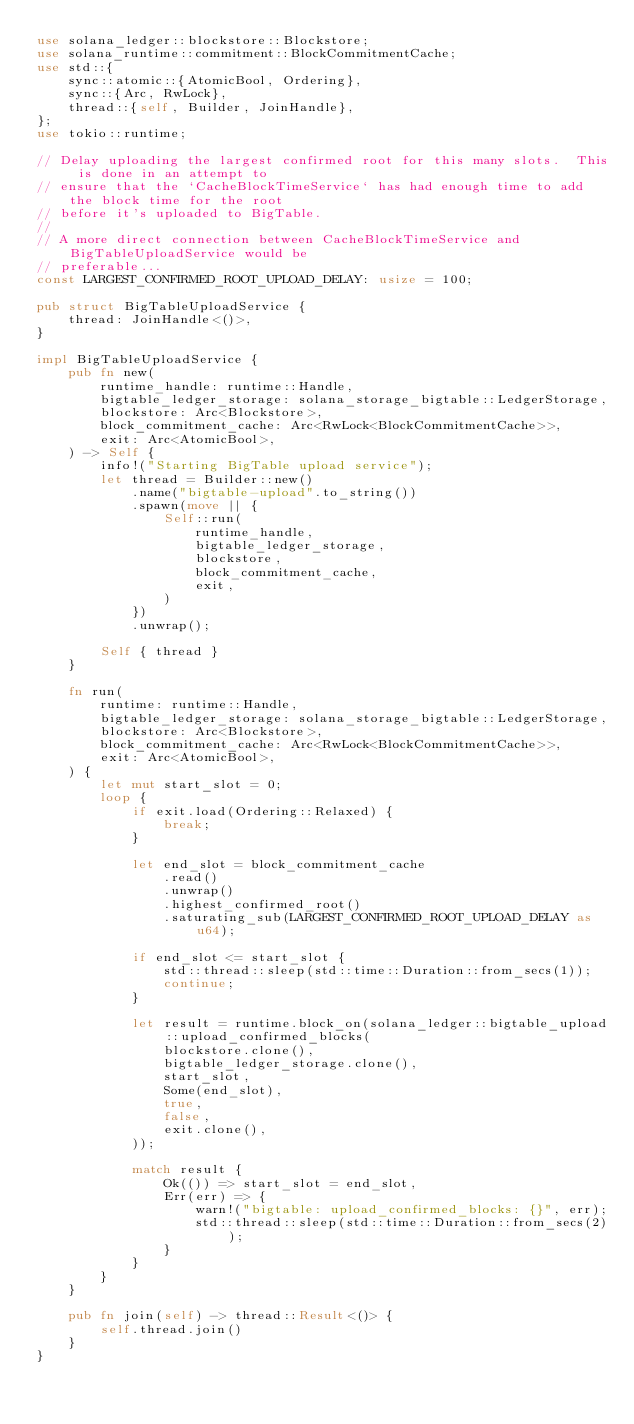Convert code to text. <code><loc_0><loc_0><loc_500><loc_500><_Rust_>use solana_ledger::blockstore::Blockstore;
use solana_runtime::commitment::BlockCommitmentCache;
use std::{
    sync::atomic::{AtomicBool, Ordering},
    sync::{Arc, RwLock},
    thread::{self, Builder, JoinHandle},
};
use tokio::runtime;

// Delay uploading the largest confirmed root for this many slots.  This is done in an attempt to
// ensure that the `CacheBlockTimeService` has had enough time to add the block time for the root
// before it's uploaded to BigTable.
//
// A more direct connection between CacheBlockTimeService and BigTableUploadService would be
// preferable...
const LARGEST_CONFIRMED_ROOT_UPLOAD_DELAY: usize = 100;

pub struct BigTableUploadService {
    thread: JoinHandle<()>,
}

impl BigTableUploadService {
    pub fn new(
        runtime_handle: runtime::Handle,
        bigtable_ledger_storage: solana_storage_bigtable::LedgerStorage,
        blockstore: Arc<Blockstore>,
        block_commitment_cache: Arc<RwLock<BlockCommitmentCache>>,
        exit: Arc<AtomicBool>,
    ) -> Self {
        info!("Starting BigTable upload service");
        let thread = Builder::new()
            .name("bigtable-upload".to_string())
            .spawn(move || {
                Self::run(
                    runtime_handle,
                    bigtable_ledger_storage,
                    blockstore,
                    block_commitment_cache,
                    exit,
                )
            })
            .unwrap();

        Self { thread }
    }

    fn run(
        runtime: runtime::Handle,
        bigtable_ledger_storage: solana_storage_bigtable::LedgerStorage,
        blockstore: Arc<Blockstore>,
        block_commitment_cache: Arc<RwLock<BlockCommitmentCache>>,
        exit: Arc<AtomicBool>,
    ) {
        let mut start_slot = 0;
        loop {
            if exit.load(Ordering::Relaxed) {
                break;
            }

            let end_slot = block_commitment_cache
                .read()
                .unwrap()
                .highest_confirmed_root()
                .saturating_sub(LARGEST_CONFIRMED_ROOT_UPLOAD_DELAY as u64);

            if end_slot <= start_slot {
                std::thread::sleep(std::time::Duration::from_secs(1));
                continue;
            }

            let result = runtime.block_on(solana_ledger::bigtable_upload::upload_confirmed_blocks(
                blockstore.clone(),
                bigtable_ledger_storage.clone(),
                start_slot,
                Some(end_slot),
                true,
                false,
                exit.clone(),
            ));

            match result {
                Ok(()) => start_slot = end_slot,
                Err(err) => {
                    warn!("bigtable: upload_confirmed_blocks: {}", err);
                    std::thread::sleep(std::time::Duration::from_secs(2));
                }
            }
        }
    }

    pub fn join(self) -> thread::Result<()> {
        self.thread.join()
    }
}
</code> 